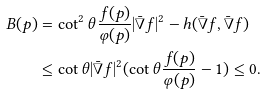Convert formula to latex. <formula><loc_0><loc_0><loc_500><loc_500>B ( p ) & = \cot ^ { 2 } \theta \frac { f ( p ) } { \varphi ( p ) } | \bar { \nabla } f | ^ { 2 } - h ( \bar { \nabla } f , \bar { \nabla } f ) \\ & \leq \cot \theta | \bar { \nabla } f | ^ { 2 } ( \cot \theta \frac { f ( p ) } { \varphi ( p ) } - 1 ) \leq 0 .</formula> 